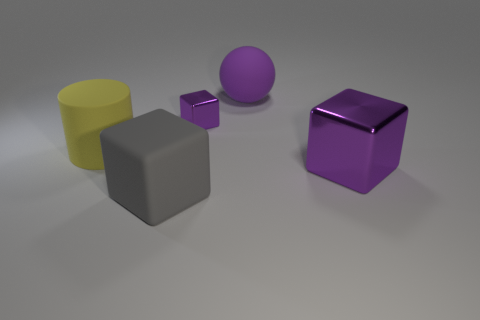Add 5 purple matte balls. How many objects exist? 10 Subtract all large gray blocks. How many blocks are left? 2 Add 4 big purple shiny objects. How many big purple shiny objects are left? 5 Add 4 matte cylinders. How many matte cylinders exist? 5 Subtract all gray cubes. How many cubes are left? 2 Subtract 0 yellow cubes. How many objects are left? 5 Subtract all spheres. How many objects are left? 4 Subtract 1 cylinders. How many cylinders are left? 0 Subtract all purple cylinders. Subtract all brown balls. How many cylinders are left? 1 Subtract all red cylinders. How many gray cubes are left? 1 